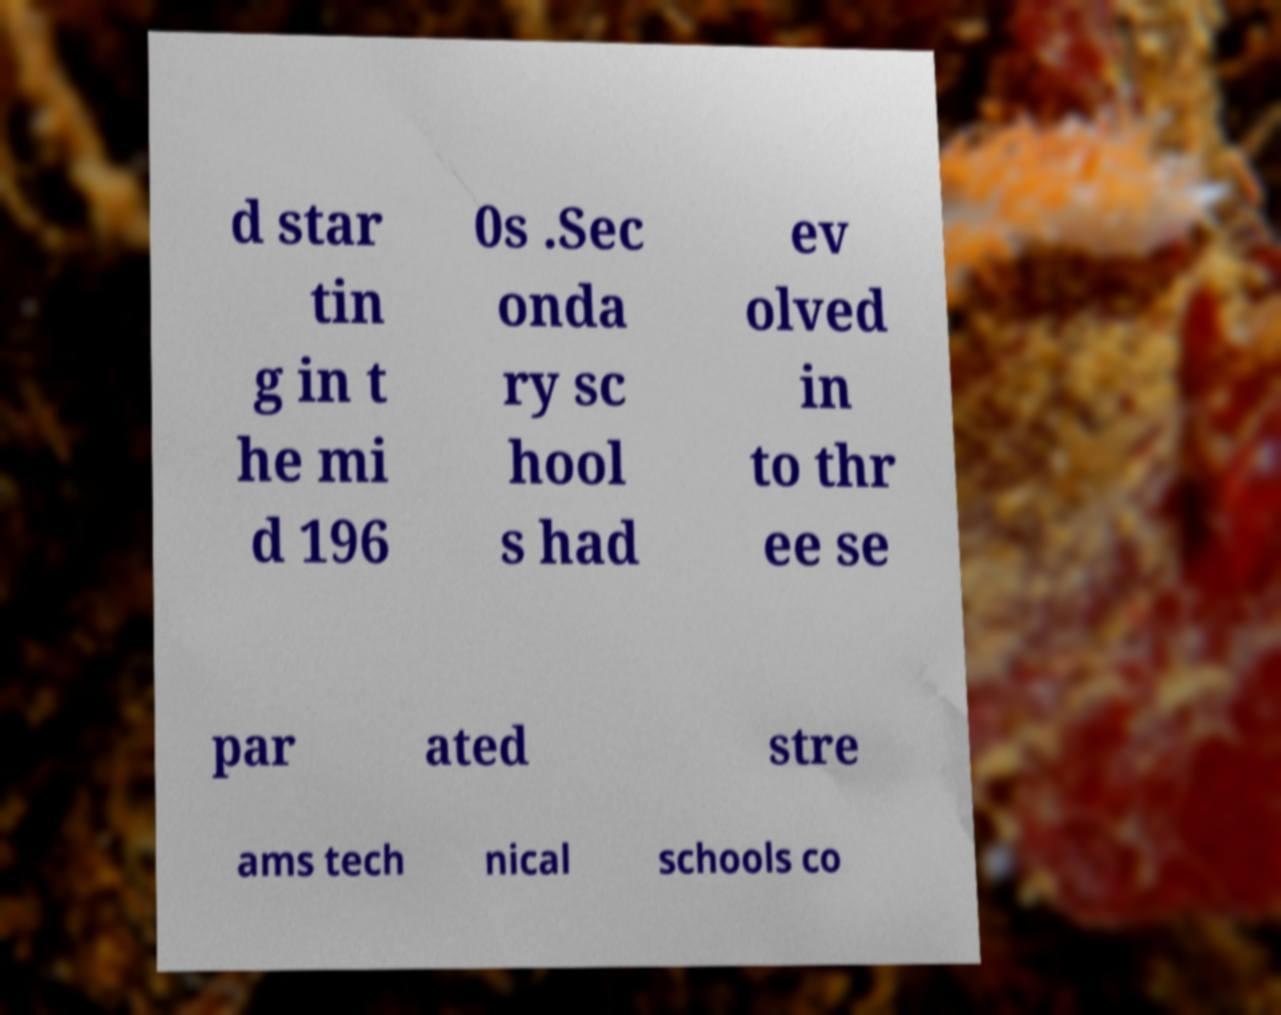Could you assist in decoding the text presented in this image and type it out clearly? d star tin g in t he mi d 196 0s .Sec onda ry sc hool s had ev olved in to thr ee se par ated stre ams tech nical schools co 